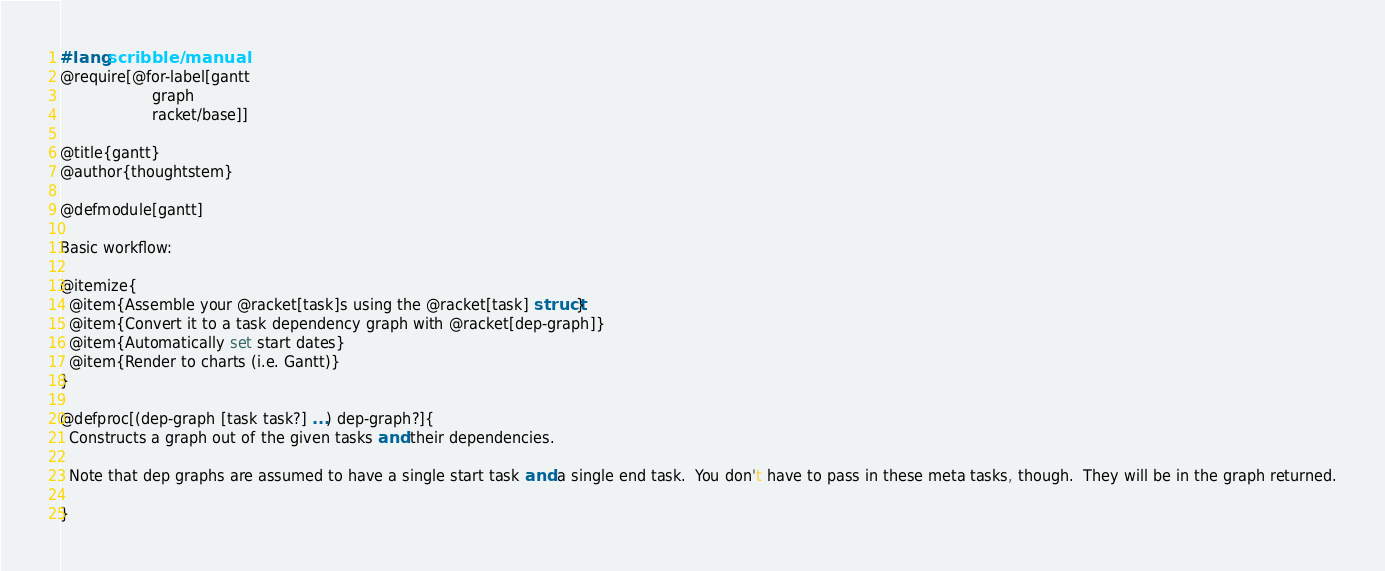<code> <loc_0><loc_0><loc_500><loc_500><_Racket_>#lang scribble/manual
@require[@for-label[gantt
                    graph
                    racket/base]]

@title{gantt}
@author{thoughtstem}

@defmodule[gantt]

Basic workflow: 

@itemize{
  @item{Assemble your @racket[task]s using the @racket[task] struct}
  @item{Convert it to a task dependency graph with @racket[dep-graph]}
  @item{Automatically set start dates}
  @item{Render to charts (i.e. Gantt)}
}

@defproc[(dep-graph [task task?] ...) dep-graph?]{
  Constructs a graph out of the given tasks and their dependencies.

  Note that dep graphs are assumed to have a single start task and a single end task.  You don't have to pass in these meta tasks, though.  They will be in the graph returned.

}
</code> 